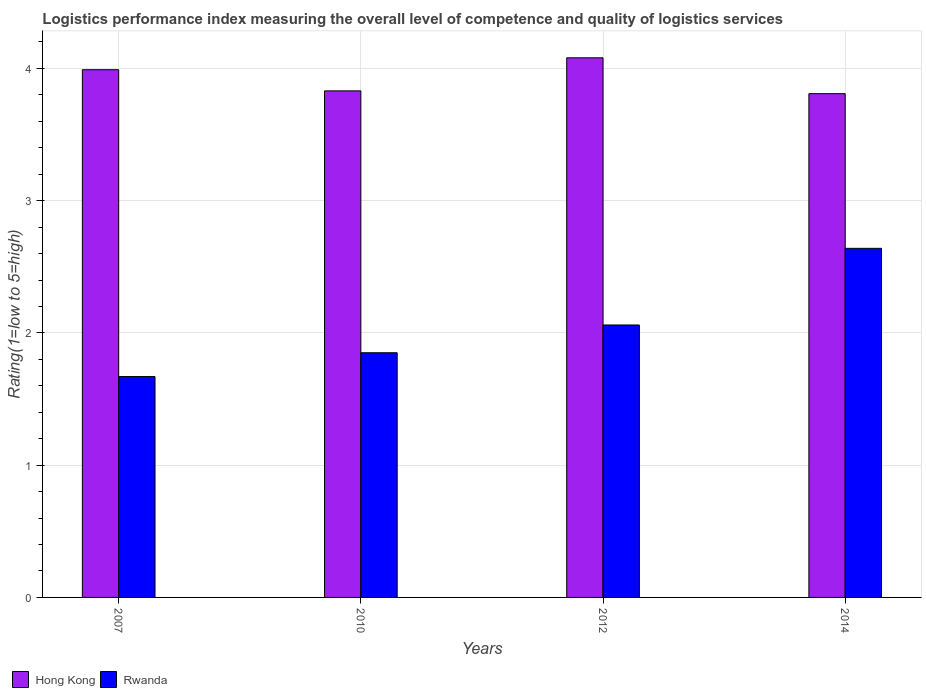How many groups of bars are there?
Ensure brevity in your answer.  4. How many bars are there on the 3rd tick from the left?
Offer a terse response. 2. How many bars are there on the 1st tick from the right?
Your answer should be compact. 2. What is the label of the 1st group of bars from the left?
Provide a short and direct response. 2007. In how many cases, is the number of bars for a given year not equal to the number of legend labels?
Offer a very short reply. 0. What is the Logistic performance index in Hong Kong in 2007?
Your response must be concise. 3.99. Across all years, what is the maximum Logistic performance index in Rwanda?
Your answer should be compact. 2.64. Across all years, what is the minimum Logistic performance index in Rwanda?
Your response must be concise. 1.67. In which year was the Logistic performance index in Rwanda minimum?
Provide a short and direct response. 2007. What is the total Logistic performance index in Rwanda in the graph?
Your answer should be compact. 8.22. What is the difference between the Logistic performance index in Rwanda in 2007 and that in 2012?
Your answer should be compact. -0.39. What is the difference between the Logistic performance index in Hong Kong in 2007 and the Logistic performance index in Rwanda in 2010?
Your answer should be compact. 2.14. What is the average Logistic performance index in Hong Kong per year?
Make the answer very short. 3.93. In the year 2012, what is the difference between the Logistic performance index in Hong Kong and Logistic performance index in Rwanda?
Your answer should be very brief. 2.02. In how many years, is the Logistic performance index in Rwanda greater than 1.2?
Make the answer very short. 4. What is the ratio of the Logistic performance index in Hong Kong in 2010 to that in 2012?
Provide a short and direct response. 0.94. Is the Logistic performance index in Rwanda in 2007 less than that in 2012?
Provide a short and direct response. Yes. What is the difference between the highest and the second highest Logistic performance index in Rwanda?
Provide a succinct answer. 0.58. What is the difference between the highest and the lowest Logistic performance index in Hong Kong?
Give a very brief answer. 0.27. Is the sum of the Logistic performance index in Hong Kong in 2007 and 2012 greater than the maximum Logistic performance index in Rwanda across all years?
Your answer should be very brief. Yes. What does the 2nd bar from the left in 2012 represents?
Provide a short and direct response. Rwanda. What does the 2nd bar from the right in 2014 represents?
Provide a short and direct response. Hong Kong. Are all the bars in the graph horizontal?
Provide a short and direct response. No. How many years are there in the graph?
Keep it short and to the point. 4. How many legend labels are there?
Give a very brief answer. 2. How are the legend labels stacked?
Offer a terse response. Horizontal. What is the title of the graph?
Ensure brevity in your answer.  Logistics performance index measuring the overall level of competence and quality of logistics services. What is the label or title of the X-axis?
Keep it short and to the point. Years. What is the label or title of the Y-axis?
Ensure brevity in your answer.  Rating(1=low to 5=high). What is the Rating(1=low to 5=high) in Hong Kong in 2007?
Offer a very short reply. 3.99. What is the Rating(1=low to 5=high) in Rwanda in 2007?
Your answer should be very brief. 1.67. What is the Rating(1=low to 5=high) of Hong Kong in 2010?
Provide a short and direct response. 3.83. What is the Rating(1=low to 5=high) of Rwanda in 2010?
Your response must be concise. 1.85. What is the Rating(1=low to 5=high) of Hong Kong in 2012?
Your answer should be very brief. 4.08. What is the Rating(1=low to 5=high) of Rwanda in 2012?
Your answer should be very brief. 2.06. What is the Rating(1=low to 5=high) of Hong Kong in 2014?
Ensure brevity in your answer.  3.81. What is the Rating(1=low to 5=high) of Rwanda in 2014?
Keep it short and to the point. 2.64. Across all years, what is the maximum Rating(1=low to 5=high) of Hong Kong?
Your answer should be very brief. 4.08. Across all years, what is the maximum Rating(1=low to 5=high) in Rwanda?
Offer a very short reply. 2.64. Across all years, what is the minimum Rating(1=low to 5=high) of Hong Kong?
Ensure brevity in your answer.  3.81. Across all years, what is the minimum Rating(1=low to 5=high) of Rwanda?
Your response must be concise. 1.67. What is the total Rating(1=low to 5=high) in Hong Kong in the graph?
Ensure brevity in your answer.  15.71. What is the total Rating(1=low to 5=high) in Rwanda in the graph?
Your response must be concise. 8.22. What is the difference between the Rating(1=low to 5=high) of Hong Kong in 2007 and that in 2010?
Give a very brief answer. 0.16. What is the difference between the Rating(1=low to 5=high) in Rwanda in 2007 and that in 2010?
Provide a succinct answer. -0.18. What is the difference between the Rating(1=low to 5=high) of Hong Kong in 2007 and that in 2012?
Your response must be concise. -0.09. What is the difference between the Rating(1=low to 5=high) in Rwanda in 2007 and that in 2012?
Your answer should be very brief. -0.39. What is the difference between the Rating(1=low to 5=high) in Hong Kong in 2007 and that in 2014?
Give a very brief answer. 0.18. What is the difference between the Rating(1=low to 5=high) in Rwanda in 2007 and that in 2014?
Keep it short and to the point. -0.97. What is the difference between the Rating(1=low to 5=high) in Hong Kong in 2010 and that in 2012?
Your answer should be very brief. -0.25. What is the difference between the Rating(1=low to 5=high) in Rwanda in 2010 and that in 2012?
Offer a very short reply. -0.21. What is the difference between the Rating(1=low to 5=high) in Hong Kong in 2010 and that in 2014?
Provide a short and direct response. 0.02. What is the difference between the Rating(1=low to 5=high) in Rwanda in 2010 and that in 2014?
Your response must be concise. -0.79. What is the difference between the Rating(1=low to 5=high) of Hong Kong in 2012 and that in 2014?
Offer a very short reply. 0.27. What is the difference between the Rating(1=low to 5=high) in Rwanda in 2012 and that in 2014?
Offer a very short reply. -0.58. What is the difference between the Rating(1=low to 5=high) of Hong Kong in 2007 and the Rating(1=low to 5=high) of Rwanda in 2010?
Your answer should be compact. 2.14. What is the difference between the Rating(1=low to 5=high) of Hong Kong in 2007 and the Rating(1=low to 5=high) of Rwanda in 2012?
Provide a succinct answer. 1.93. What is the difference between the Rating(1=low to 5=high) of Hong Kong in 2007 and the Rating(1=low to 5=high) of Rwanda in 2014?
Your response must be concise. 1.35. What is the difference between the Rating(1=low to 5=high) in Hong Kong in 2010 and the Rating(1=low to 5=high) in Rwanda in 2012?
Your answer should be compact. 1.77. What is the difference between the Rating(1=low to 5=high) of Hong Kong in 2010 and the Rating(1=low to 5=high) of Rwanda in 2014?
Offer a terse response. 1.19. What is the difference between the Rating(1=low to 5=high) in Hong Kong in 2012 and the Rating(1=low to 5=high) in Rwanda in 2014?
Offer a terse response. 1.44. What is the average Rating(1=low to 5=high) of Hong Kong per year?
Offer a terse response. 3.93. What is the average Rating(1=low to 5=high) of Rwanda per year?
Your answer should be very brief. 2.05. In the year 2007, what is the difference between the Rating(1=low to 5=high) of Hong Kong and Rating(1=low to 5=high) of Rwanda?
Make the answer very short. 2.32. In the year 2010, what is the difference between the Rating(1=low to 5=high) of Hong Kong and Rating(1=low to 5=high) of Rwanda?
Your response must be concise. 1.98. In the year 2012, what is the difference between the Rating(1=low to 5=high) of Hong Kong and Rating(1=low to 5=high) of Rwanda?
Make the answer very short. 2.02. In the year 2014, what is the difference between the Rating(1=low to 5=high) in Hong Kong and Rating(1=low to 5=high) in Rwanda?
Offer a very short reply. 1.17. What is the ratio of the Rating(1=low to 5=high) of Hong Kong in 2007 to that in 2010?
Offer a very short reply. 1.04. What is the ratio of the Rating(1=low to 5=high) of Rwanda in 2007 to that in 2010?
Your response must be concise. 0.9. What is the ratio of the Rating(1=low to 5=high) in Hong Kong in 2007 to that in 2012?
Keep it short and to the point. 0.98. What is the ratio of the Rating(1=low to 5=high) of Rwanda in 2007 to that in 2012?
Make the answer very short. 0.81. What is the ratio of the Rating(1=low to 5=high) of Hong Kong in 2007 to that in 2014?
Keep it short and to the point. 1.05. What is the ratio of the Rating(1=low to 5=high) of Rwanda in 2007 to that in 2014?
Your answer should be very brief. 0.63. What is the ratio of the Rating(1=low to 5=high) in Hong Kong in 2010 to that in 2012?
Offer a very short reply. 0.94. What is the ratio of the Rating(1=low to 5=high) in Rwanda in 2010 to that in 2012?
Your answer should be very brief. 0.9. What is the ratio of the Rating(1=low to 5=high) of Hong Kong in 2010 to that in 2014?
Ensure brevity in your answer.  1.01. What is the ratio of the Rating(1=low to 5=high) of Rwanda in 2010 to that in 2014?
Make the answer very short. 0.7. What is the ratio of the Rating(1=low to 5=high) in Hong Kong in 2012 to that in 2014?
Offer a very short reply. 1.07. What is the ratio of the Rating(1=low to 5=high) in Rwanda in 2012 to that in 2014?
Give a very brief answer. 0.78. What is the difference between the highest and the second highest Rating(1=low to 5=high) of Hong Kong?
Your response must be concise. 0.09. What is the difference between the highest and the second highest Rating(1=low to 5=high) of Rwanda?
Provide a succinct answer. 0.58. What is the difference between the highest and the lowest Rating(1=low to 5=high) of Hong Kong?
Give a very brief answer. 0.27. What is the difference between the highest and the lowest Rating(1=low to 5=high) of Rwanda?
Your response must be concise. 0.97. 